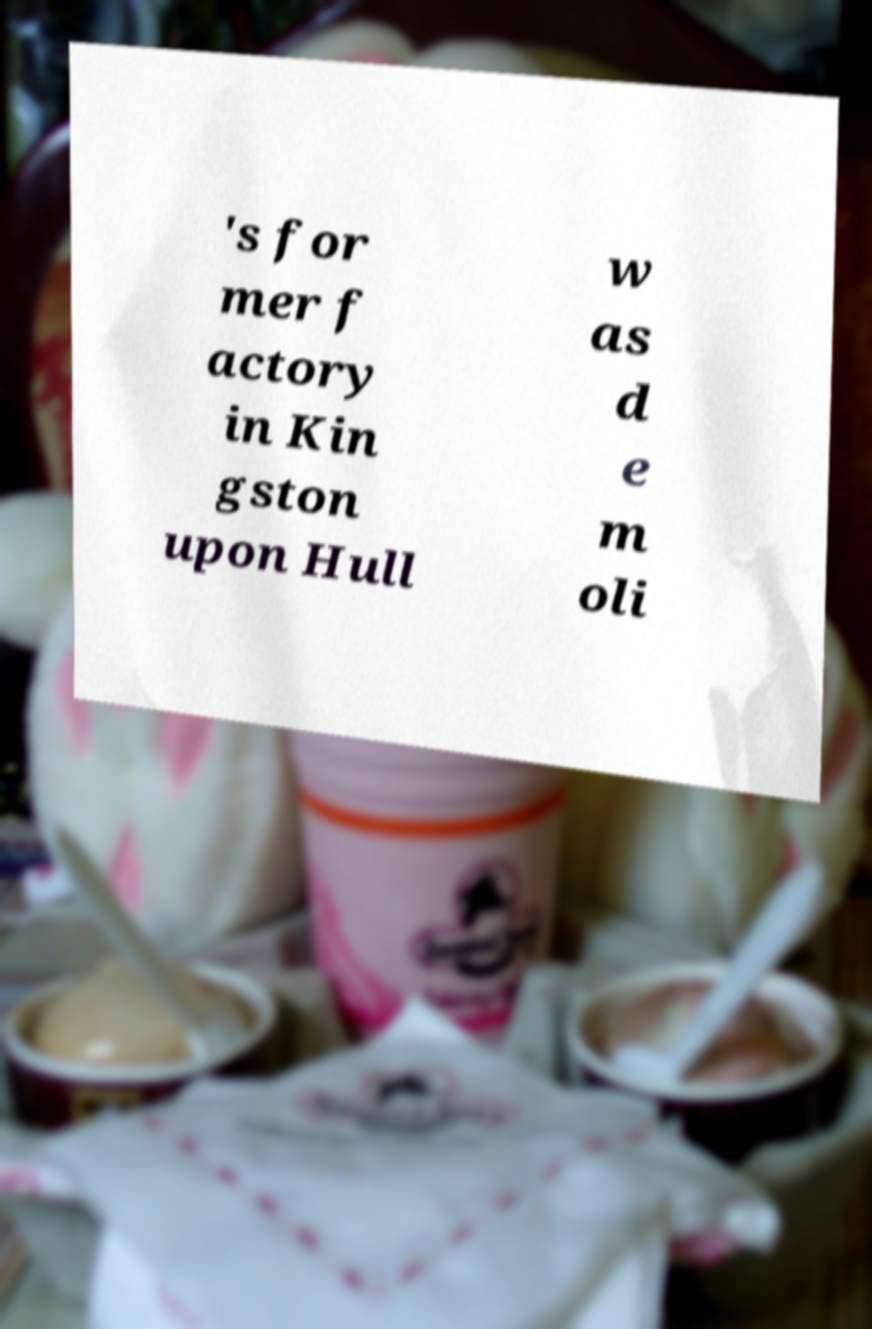What messages or text are displayed in this image? I need them in a readable, typed format. 's for mer f actory in Kin gston upon Hull w as d e m oli 